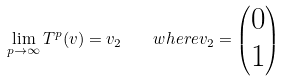<formula> <loc_0><loc_0><loc_500><loc_500>\lim _ { p \rightarrow \infty } T ^ { p } ( v ) = v _ { 2 } \quad w h e r e v _ { 2 } = \left ( \begin{matrix} 0 \\ 1 \end{matrix} \right )</formula> 